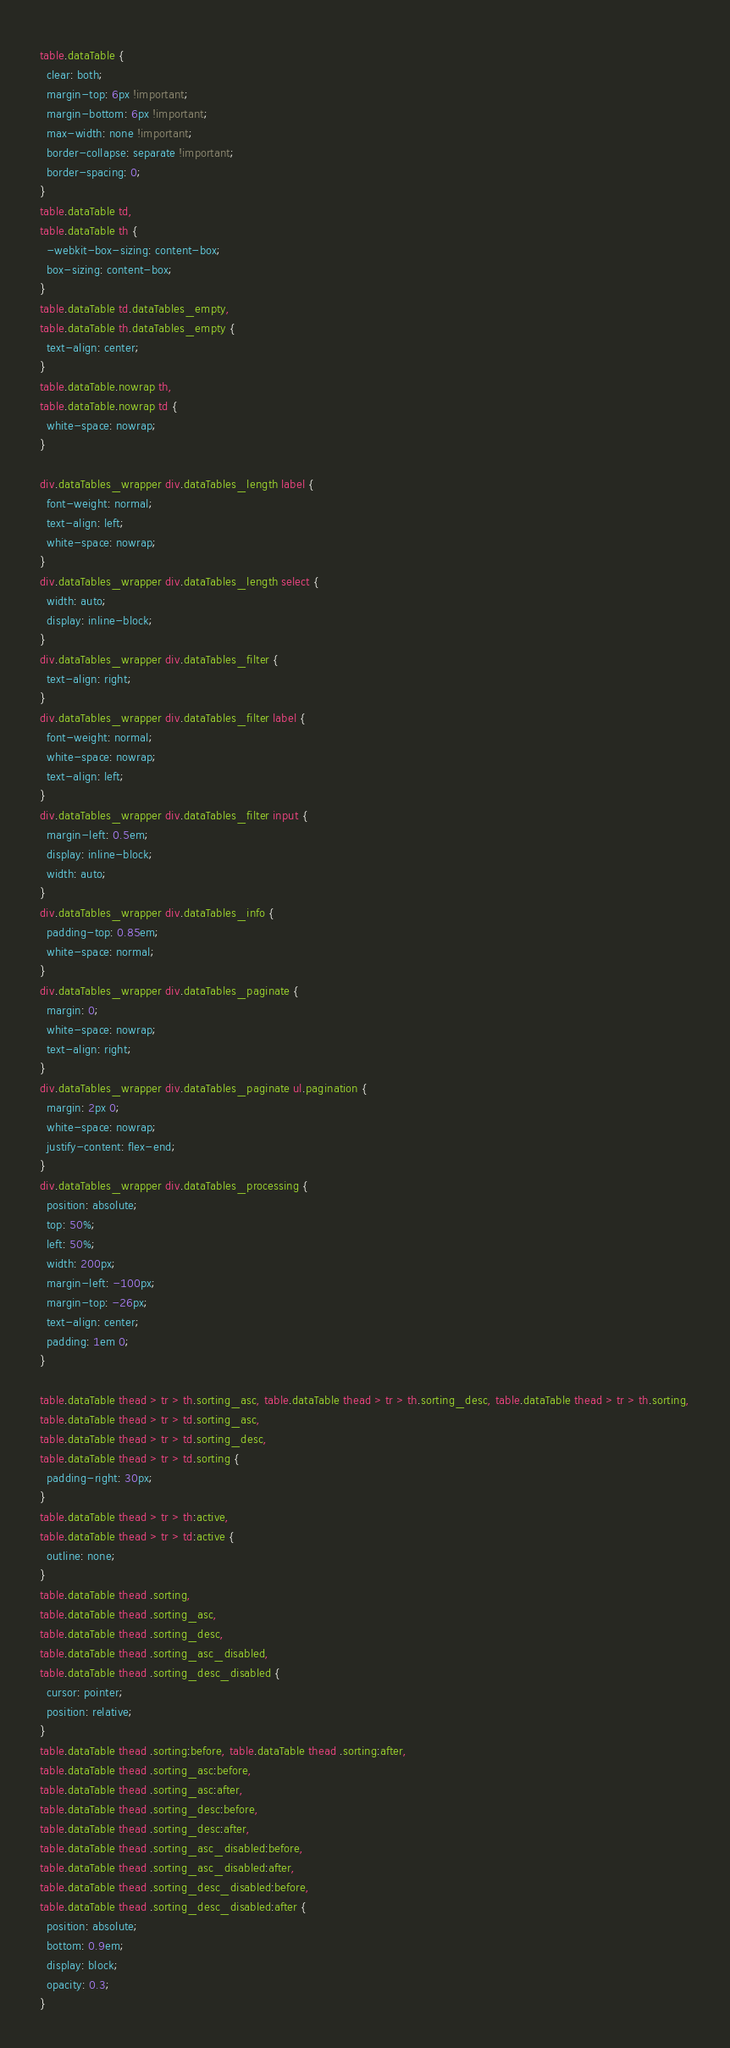Convert code to text. <code><loc_0><loc_0><loc_500><loc_500><_CSS_>table.dataTable {
  clear: both;
  margin-top: 6px !important;
  margin-bottom: 6px !important;
  max-width: none !important;
  border-collapse: separate !important;
  border-spacing: 0;
}
table.dataTable td,
table.dataTable th {
  -webkit-box-sizing: content-box;
  box-sizing: content-box;
}
table.dataTable td.dataTables_empty,
table.dataTable th.dataTables_empty {
  text-align: center;
}
table.dataTable.nowrap th,
table.dataTable.nowrap td {
  white-space: nowrap;
}

div.dataTables_wrapper div.dataTables_length label {
  font-weight: normal;
  text-align: left;
  white-space: nowrap;
}
div.dataTables_wrapper div.dataTables_length select {
  width: auto;
  display: inline-block;
}
div.dataTables_wrapper div.dataTables_filter {
  text-align: right;
}
div.dataTables_wrapper div.dataTables_filter label {
  font-weight: normal;
  white-space: nowrap;
  text-align: left;
}
div.dataTables_wrapper div.dataTables_filter input {
  margin-left: 0.5em;
  display: inline-block;
  width: auto;
}
div.dataTables_wrapper div.dataTables_info {
  padding-top: 0.85em;
  white-space: normal;
}
div.dataTables_wrapper div.dataTables_paginate {
  margin: 0;
  white-space: nowrap;
  text-align: right;
}
div.dataTables_wrapper div.dataTables_paginate ul.pagination {
  margin: 2px 0;
  white-space: nowrap;
  justify-content: flex-end;
}
div.dataTables_wrapper div.dataTables_processing {
  position: absolute;
  top: 50%;
  left: 50%;
  width: 200px;
  margin-left: -100px;
  margin-top: -26px;
  text-align: center;
  padding: 1em 0;
}

table.dataTable thead > tr > th.sorting_asc, table.dataTable thead > tr > th.sorting_desc, table.dataTable thead > tr > th.sorting,
table.dataTable thead > tr > td.sorting_asc,
table.dataTable thead > tr > td.sorting_desc,
table.dataTable thead > tr > td.sorting {
  padding-right: 30px;
}
table.dataTable thead > tr > th:active,
table.dataTable thead > tr > td:active {
  outline: none;
}
table.dataTable thead .sorting,
table.dataTable thead .sorting_asc,
table.dataTable thead .sorting_desc,
table.dataTable thead .sorting_asc_disabled,
table.dataTable thead .sorting_desc_disabled {
  cursor: pointer;
  position: relative;
}
table.dataTable thead .sorting:before, table.dataTable thead .sorting:after,
table.dataTable thead .sorting_asc:before,
table.dataTable thead .sorting_asc:after,
table.dataTable thead .sorting_desc:before,
table.dataTable thead .sorting_desc:after,
table.dataTable thead .sorting_asc_disabled:before,
table.dataTable thead .sorting_asc_disabled:after,
table.dataTable thead .sorting_desc_disabled:before,
table.dataTable thead .sorting_desc_disabled:after {
  position: absolute;
  bottom: 0.9em;
  display: block;
  opacity: 0.3;
}</code> 